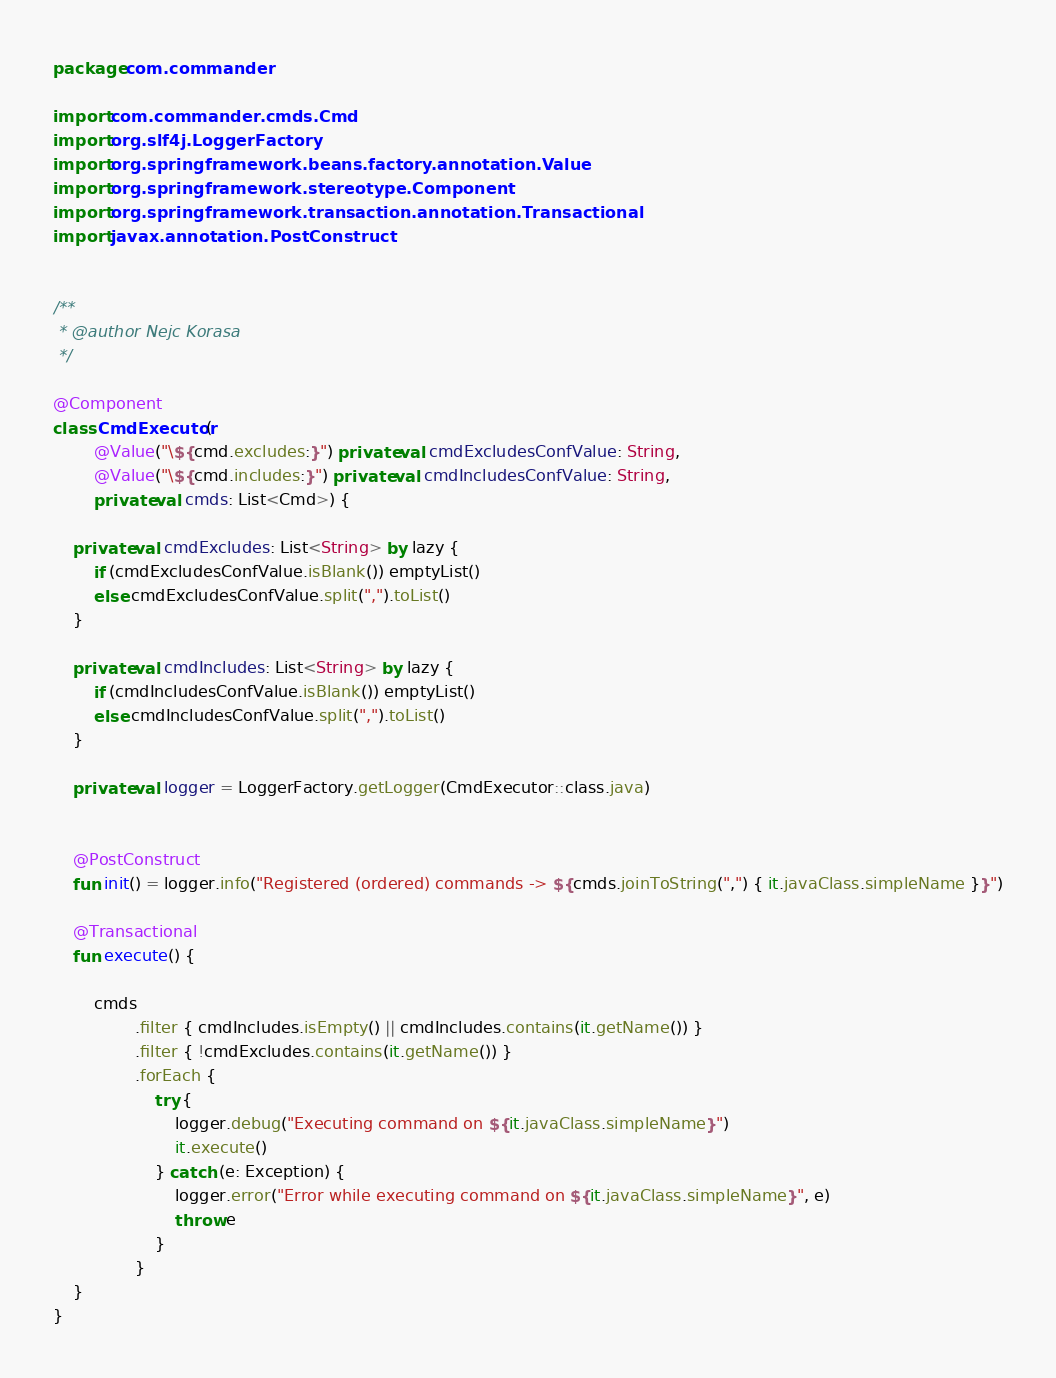Convert code to text. <code><loc_0><loc_0><loc_500><loc_500><_Kotlin_>package com.commander

import com.commander.cmds.Cmd
import org.slf4j.LoggerFactory
import org.springframework.beans.factory.annotation.Value
import org.springframework.stereotype.Component
import org.springframework.transaction.annotation.Transactional
import javax.annotation.PostConstruct


/**
 * @author Nejc Korasa
 */

@Component
class CmdExecutor(
        @Value("\${cmd.excludes:}") private val cmdExcludesConfValue: String,
        @Value("\${cmd.includes:}") private val cmdIncludesConfValue: String,
        private val cmds: List<Cmd>) {

    private val cmdExcludes: List<String> by lazy {
        if (cmdExcludesConfValue.isBlank()) emptyList()
        else cmdExcludesConfValue.split(",").toList()
    }

    private val cmdIncludes: List<String> by lazy {
        if (cmdIncludesConfValue.isBlank()) emptyList()
        else cmdIncludesConfValue.split(",").toList()
    }

    private val logger = LoggerFactory.getLogger(CmdExecutor::class.java)


    @PostConstruct
    fun init() = logger.info("Registered (ordered) commands -> ${cmds.joinToString(",") { it.javaClass.simpleName }}")

    @Transactional
    fun execute() {

        cmds
                .filter { cmdIncludes.isEmpty() || cmdIncludes.contains(it.getName()) }
                .filter { !cmdExcludes.contains(it.getName()) }
                .forEach {
                    try {
                        logger.debug("Executing command on ${it.javaClass.simpleName}")
                        it.execute()
                    } catch (e: Exception) {
                        logger.error("Error while executing command on ${it.javaClass.simpleName}", e)
                        throw e
                    }
                }
    }
}</code> 